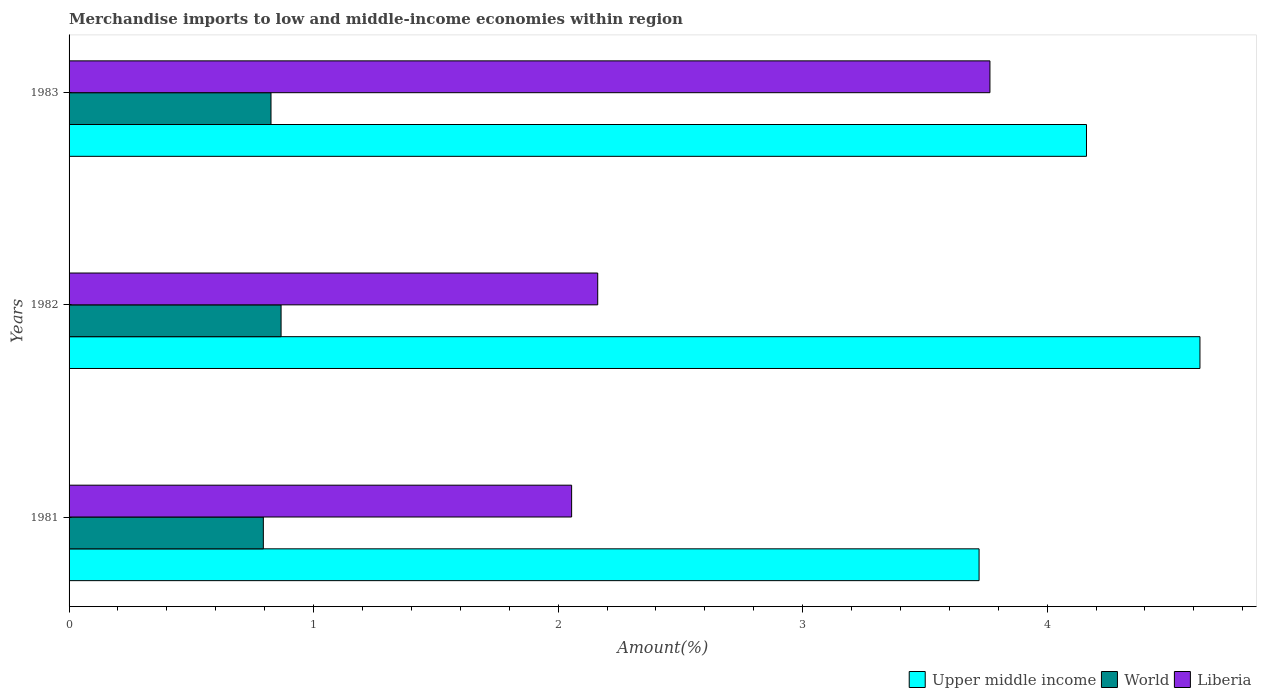How many groups of bars are there?
Provide a succinct answer. 3. In how many cases, is the number of bars for a given year not equal to the number of legend labels?
Give a very brief answer. 0. What is the percentage of amount earned from merchandise imports in World in 1982?
Keep it short and to the point. 0.87. Across all years, what is the maximum percentage of amount earned from merchandise imports in World?
Offer a very short reply. 0.87. Across all years, what is the minimum percentage of amount earned from merchandise imports in World?
Offer a very short reply. 0.79. In which year was the percentage of amount earned from merchandise imports in World maximum?
Ensure brevity in your answer.  1982. What is the total percentage of amount earned from merchandise imports in World in the graph?
Provide a succinct answer. 2.49. What is the difference between the percentage of amount earned from merchandise imports in World in 1982 and that in 1983?
Make the answer very short. 0.04. What is the difference between the percentage of amount earned from merchandise imports in Upper middle income in 1981 and the percentage of amount earned from merchandise imports in Liberia in 1983?
Offer a very short reply. -0.04. What is the average percentage of amount earned from merchandise imports in Upper middle income per year?
Make the answer very short. 4.17. In the year 1981, what is the difference between the percentage of amount earned from merchandise imports in World and percentage of amount earned from merchandise imports in Liberia?
Offer a terse response. -1.26. What is the ratio of the percentage of amount earned from merchandise imports in Upper middle income in 1981 to that in 1983?
Your answer should be very brief. 0.89. Is the percentage of amount earned from merchandise imports in World in 1981 less than that in 1982?
Offer a terse response. Yes. What is the difference between the highest and the second highest percentage of amount earned from merchandise imports in Upper middle income?
Your answer should be very brief. 0.46. What is the difference between the highest and the lowest percentage of amount earned from merchandise imports in Liberia?
Your response must be concise. 1.71. In how many years, is the percentage of amount earned from merchandise imports in Upper middle income greater than the average percentage of amount earned from merchandise imports in Upper middle income taken over all years?
Your answer should be compact. 1. Is the sum of the percentage of amount earned from merchandise imports in World in 1981 and 1983 greater than the maximum percentage of amount earned from merchandise imports in Liberia across all years?
Give a very brief answer. No. What does the 1st bar from the top in 1982 represents?
Ensure brevity in your answer.  Liberia. What does the 3rd bar from the bottom in 1983 represents?
Give a very brief answer. Liberia. Are all the bars in the graph horizontal?
Give a very brief answer. Yes. How many years are there in the graph?
Keep it short and to the point. 3. Are the values on the major ticks of X-axis written in scientific E-notation?
Provide a short and direct response. No. Does the graph contain grids?
Provide a short and direct response. No. Where does the legend appear in the graph?
Provide a succinct answer. Bottom right. How are the legend labels stacked?
Your answer should be very brief. Horizontal. What is the title of the graph?
Offer a very short reply. Merchandise imports to low and middle-income economies within region. What is the label or title of the X-axis?
Provide a short and direct response. Amount(%). What is the label or title of the Y-axis?
Offer a very short reply. Years. What is the Amount(%) in Upper middle income in 1981?
Give a very brief answer. 3.72. What is the Amount(%) in World in 1981?
Offer a terse response. 0.79. What is the Amount(%) of Liberia in 1981?
Offer a terse response. 2.06. What is the Amount(%) of Upper middle income in 1982?
Keep it short and to the point. 4.62. What is the Amount(%) of World in 1982?
Provide a succinct answer. 0.87. What is the Amount(%) of Liberia in 1982?
Offer a terse response. 2.16. What is the Amount(%) of Upper middle income in 1983?
Provide a short and direct response. 4.16. What is the Amount(%) in World in 1983?
Make the answer very short. 0.83. What is the Amount(%) in Liberia in 1983?
Your answer should be very brief. 3.77. Across all years, what is the maximum Amount(%) in Upper middle income?
Ensure brevity in your answer.  4.62. Across all years, what is the maximum Amount(%) of World?
Offer a very short reply. 0.87. Across all years, what is the maximum Amount(%) of Liberia?
Your response must be concise. 3.77. Across all years, what is the minimum Amount(%) of Upper middle income?
Ensure brevity in your answer.  3.72. Across all years, what is the minimum Amount(%) in World?
Provide a short and direct response. 0.79. Across all years, what is the minimum Amount(%) in Liberia?
Keep it short and to the point. 2.06. What is the total Amount(%) of Upper middle income in the graph?
Offer a terse response. 12.51. What is the total Amount(%) of World in the graph?
Your response must be concise. 2.49. What is the total Amount(%) in Liberia in the graph?
Keep it short and to the point. 7.98. What is the difference between the Amount(%) of Upper middle income in 1981 and that in 1982?
Ensure brevity in your answer.  -0.9. What is the difference between the Amount(%) of World in 1981 and that in 1982?
Give a very brief answer. -0.07. What is the difference between the Amount(%) in Liberia in 1981 and that in 1982?
Make the answer very short. -0.11. What is the difference between the Amount(%) in Upper middle income in 1981 and that in 1983?
Offer a very short reply. -0.44. What is the difference between the Amount(%) of World in 1981 and that in 1983?
Provide a succinct answer. -0.03. What is the difference between the Amount(%) of Liberia in 1981 and that in 1983?
Ensure brevity in your answer.  -1.71. What is the difference between the Amount(%) in Upper middle income in 1982 and that in 1983?
Offer a terse response. 0.46. What is the difference between the Amount(%) in World in 1982 and that in 1983?
Ensure brevity in your answer.  0.04. What is the difference between the Amount(%) in Liberia in 1982 and that in 1983?
Your answer should be compact. -1.6. What is the difference between the Amount(%) in Upper middle income in 1981 and the Amount(%) in World in 1982?
Ensure brevity in your answer.  2.85. What is the difference between the Amount(%) of Upper middle income in 1981 and the Amount(%) of Liberia in 1982?
Make the answer very short. 1.56. What is the difference between the Amount(%) of World in 1981 and the Amount(%) of Liberia in 1982?
Give a very brief answer. -1.37. What is the difference between the Amount(%) in Upper middle income in 1981 and the Amount(%) in World in 1983?
Your answer should be compact. 2.9. What is the difference between the Amount(%) of Upper middle income in 1981 and the Amount(%) of Liberia in 1983?
Keep it short and to the point. -0.04. What is the difference between the Amount(%) of World in 1981 and the Amount(%) of Liberia in 1983?
Ensure brevity in your answer.  -2.97. What is the difference between the Amount(%) in Upper middle income in 1982 and the Amount(%) in World in 1983?
Offer a very short reply. 3.8. What is the difference between the Amount(%) in Upper middle income in 1982 and the Amount(%) in Liberia in 1983?
Provide a short and direct response. 0.86. What is the difference between the Amount(%) of World in 1982 and the Amount(%) of Liberia in 1983?
Offer a terse response. -2.9. What is the average Amount(%) of Upper middle income per year?
Offer a terse response. 4.17. What is the average Amount(%) of World per year?
Make the answer very short. 0.83. What is the average Amount(%) in Liberia per year?
Provide a short and direct response. 2.66. In the year 1981, what is the difference between the Amount(%) of Upper middle income and Amount(%) of World?
Provide a short and direct response. 2.93. In the year 1981, what is the difference between the Amount(%) of Upper middle income and Amount(%) of Liberia?
Your answer should be very brief. 1.67. In the year 1981, what is the difference between the Amount(%) in World and Amount(%) in Liberia?
Offer a very short reply. -1.26. In the year 1982, what is the difference between the Amount(%) of Upper middle income and Amount(%) of World?
Ensure brevity in your answer.  3.76. In the year 1982, what is the difference between the Amount(%) of Upper middle income and Amount(%) of Liberia?
Provide a succinct answer. 2.46. In the year 1982, what is the difference between the Amount(%) of World and Amount(%) of Liberia?
Offer a very short reply. -1.29. In the year 1983, what is the difference between the Amount(%) of Upper middle income and Amount(%) of World?
Your response must be concise. 3.34. In the year 1983, what is the difference between the Amount(%) in Upper middle income and Amount(%) in Liberia?
Your answer should be compact. 0.39. In the year 1983, what is the difference between the Amount(%) in World and Amount(%) in Liberia?
Make the answer very short. -2.94. What is the ratio of the Amount(%) of Upper middle income in 1981 to that in 1982?
Make the answer very short. 0.8. What is the ratio of the Amount(%) of World in 1981 to that in 1982?
Your answer should be compact. 0.92. What is the ratio of the Amount(%) of Liberia in 1981 to that in 1982?
Keep it short and to the point. 0.95. What is the ratio of the Amount(%) in Upper middle income in 1981 to that in 1983?
Your answer should be compact. 0.89. What is the ratio of the Amount(%) of World in 1981 to that in 1983?
Provide a short and direct response. 0.96. What is the ratio of the Amount(%) in Liberia in 1981 to that in 1983?
Ensure brevity in your answer.  0.55. What is the ratio of the Amount(%) in Upper middle income in 1982 to that in 1983?
Your answer should be compact. 1.11. What is the ratio of the Amount(%) of World in 1982 to that in 1983?
Your answer should be compact. 1.05. What is the ratio of the Amount(%) in Liberia in 1982 to that in 1983?
Your answer should be compact. 0.57. What is the difference between the highest and the second highest Amount(%) in Upper middle income?
Give a very brief answer. 0.46. What is the difference between the highest and the second highest Amount(%) of World?
Your response must be concise. 0.04. What is the difference between the highest and the second highest Amount(%) of Liberia?
Your answer should be compact. 1.6. What is the difference between the highest and the lowest Amount(%) of Upper middle income?
Your answer should be very brief. 0.9. What is the difference between the highest and the lowest Amount(%) in World?
Your response must be concise. 0.07. What is the difference between the highest and the lowest Amount(%) of Liberia?
Offer a very short reply. 1.71. 